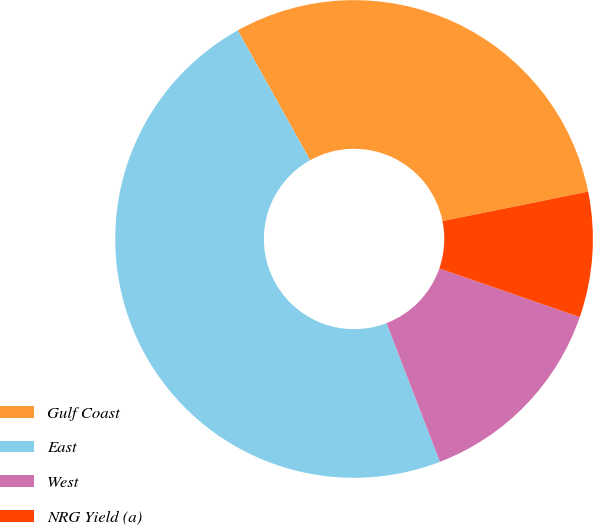Convert chart. <chart><loc_0><loc_0><loc_500><loc_500><pie_chart><fcel>Gulf Coast<fcel>East<fcel>West<fcel>NRG Yield (a)<nl><fcel>29.92%<fcel>47.76%<fcel>13.84%<fcel>8.48%<nl></chart> 